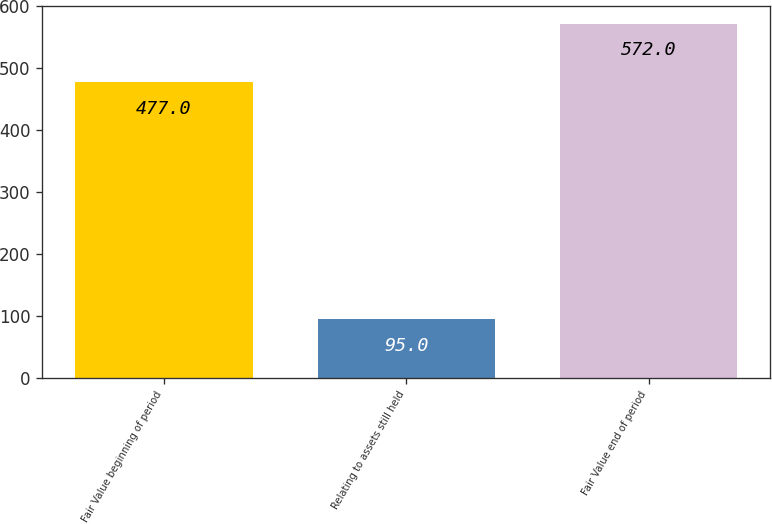<chart> <loc_0><loc_0><loc_500><loc_500><bar_chart><fcel>Fair Value beginning of period<fcel>Relating to assets still held<fcel>Fair Value end of period<nl><fcel>477<fcel>95<fcel>572<nl></chart> 